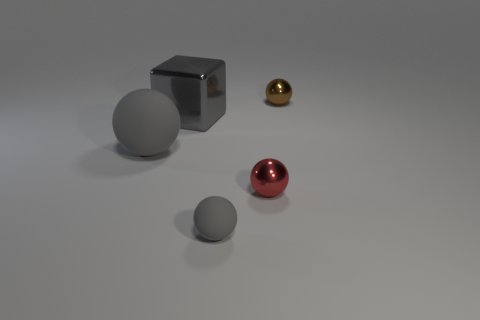What shape is the large rubber thing that is the same color as the large metal block?
Offer a terse response. Sphere. Are there any tiny red metal balls that are behind the sphere behind the rubber object behind the tiny rubber sphere?
Your answer should be very brief. No. What number of tiny spheres have the same color as the tiny matte object?
Your response must be concise. 0. There is a matte object that is the same size as the gray shiny object; what is its shape?
Give a very brief answer. Sphere. Are there any small brown objects to the left of the gray metallic thing?
Offer a very short reply. No. Do the gray shiny object and the red object have the same size?
Offer a terse response. No. There is a small shiny object that is to the left of the brown ball; what is its shape?
Provide a succinct answer. Sphere. Are there any brown shiny objects of the same size as the brown ball?
Make the answer very short. No. There is a gray thing that is the same size as the brown metal ball; what is it made of?
Ensure brevity in your answer.  Rubber. How big is the metallic sphere on the left side of the brown object?
Give a very brief answer. Small. 